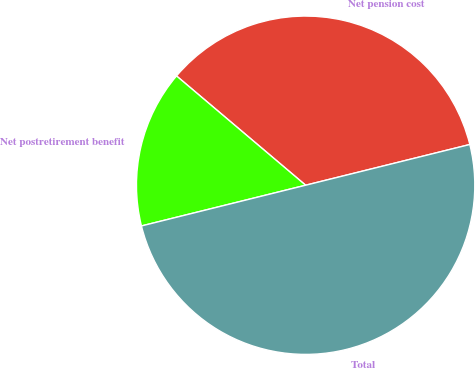<chart> <loc_0><loc_0><loc_500><loc_500><pie_chart><fcel>Net pension cost<fcel>Net postretirement benefit<fcel>Total<nl><fcel>34.95%<fcel>15.05%<fcel>50.0%<nl></chart> 